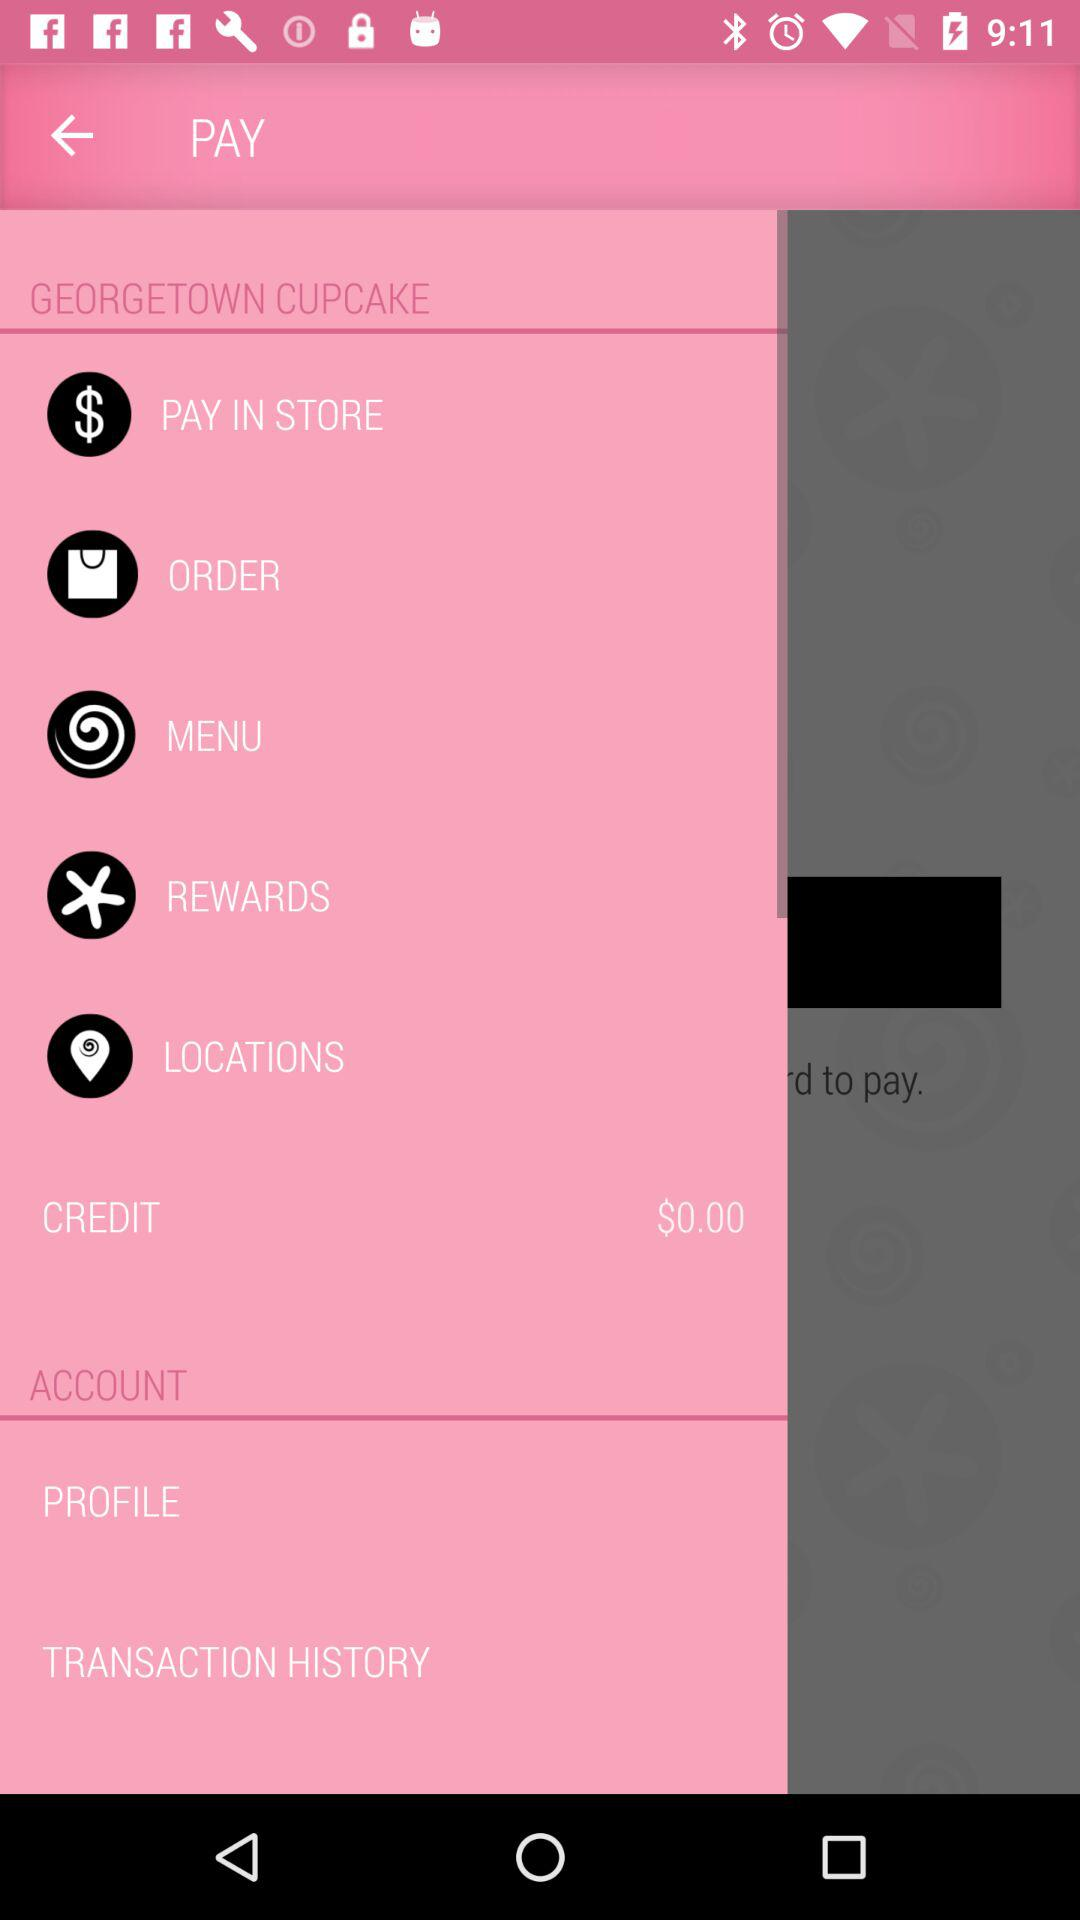How much money is in the credit balance?
Answer the question using a single word or phrase. $0.00 